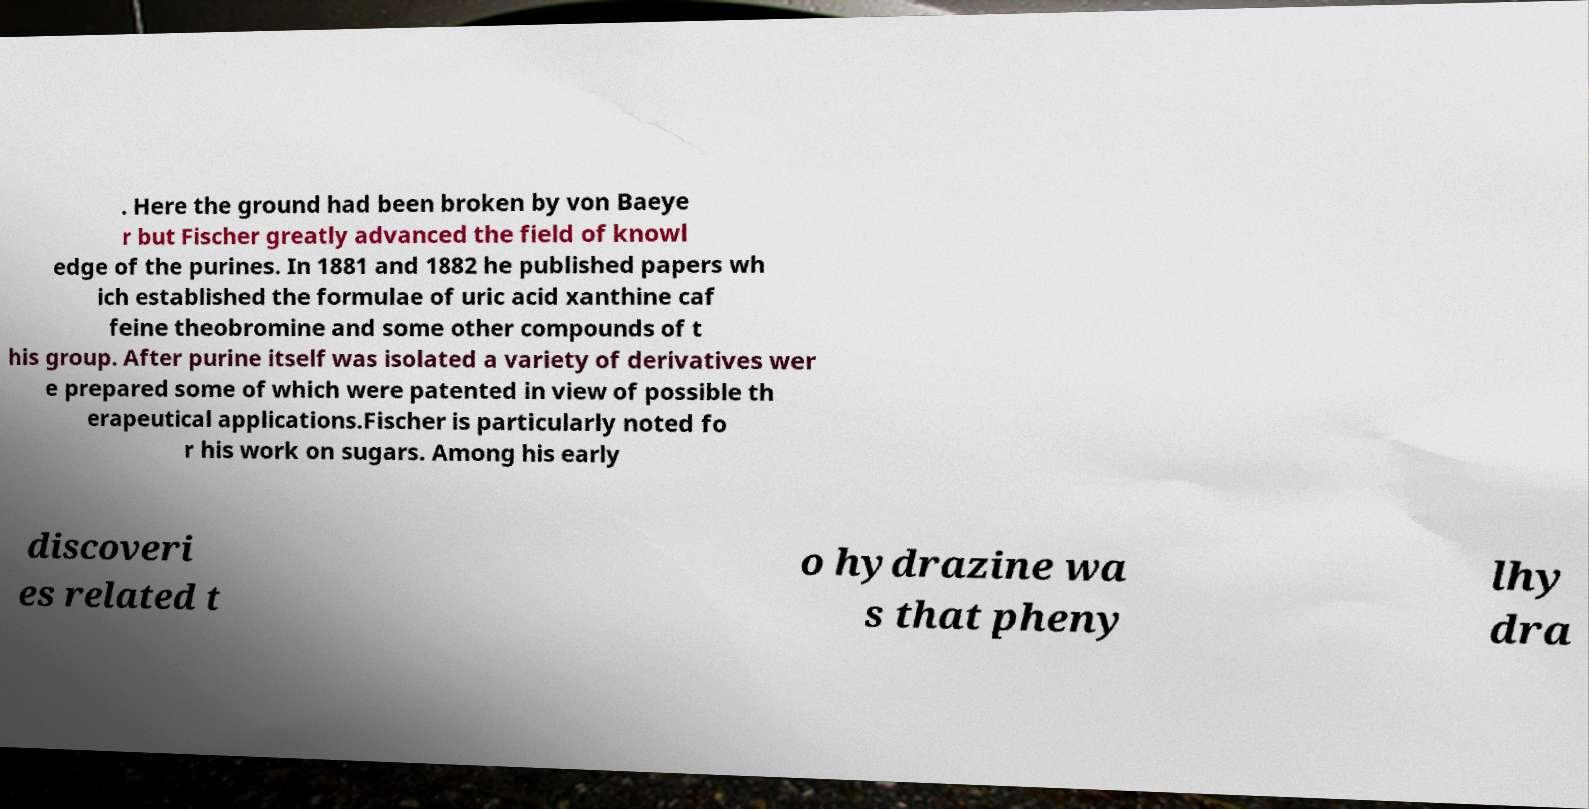What messages or text are displayed in this image? I need them in a readable, typed format. . Here the ground had been broken by von Baeye r but Fischer greatly advanced the field of knowl edge of the purines. In 1881 and 1882 he published papers wh ich established the formulae of uric acid xanthine caf feine theobromine and some other compounds of t his group. After purine itself was isolated a variety of derivatives wer e prepared some of which were patented in view of possible th erapeutical applications.Fischer is particularly noted fo r his work on sugars. Among his early discoveri es related t o hydrazine wa s that pheny lhy dra 